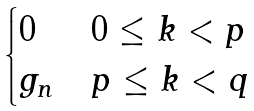Convert formula to latex. <formula><loc_0><loc_0><loc_500><loc_500>\begin{cases} 0 & 0 \leq k < p \\ g _ { n } & p \leq k < q \end{cases}</formula> 